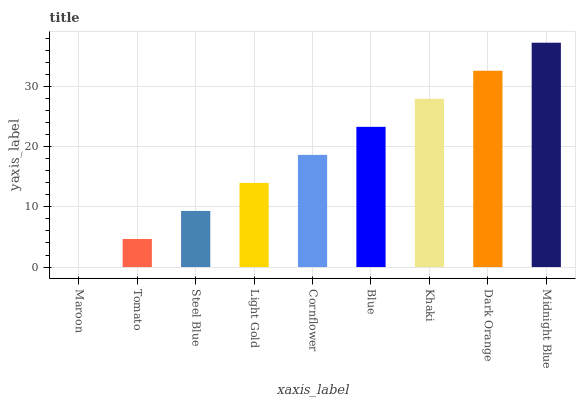Is Maroon the minimum?
Answer yes or no. Yes. Is Midnight Blue the maximum?
Answer yes or no. Yes. Is Tomato the minimum?
Answer yes or no. No. Is Tomato the maximum?
Answer yes or no. No. Is Tomato greater than Maroon?
Answer yes or no. Yes. Is Maroon less than Tomato?
Answer yes or no. Yes. Is Maroon greater than Tomato?
Answer yes or no. No. Is Tomato less than Maroon?
Answer yes or no. No. Is Cornflower the high median?
Answer yes or no. Yes. Is Cornflower the low median?
Answer yes or no. Yes. Is Maroon the high median?
Answer yes or no. No. Is Khaki the low median?
Answer yes or no. No. 